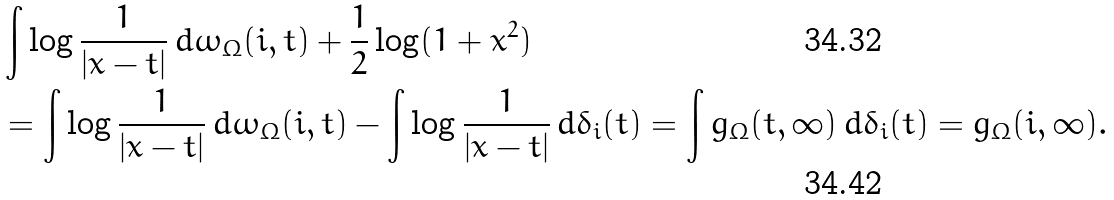<formula> <loc_0><loc_0><loc_500><loc_500>& \int \log \frac { 1 } { | x - t | } \, d \omega _ { \Omega } ( i , t ) + \frac { 1 } { 2 } \log ( 1 + x ^ { 2 } ) \\ & = \int \log \frac { 1 } { | x - t | } \, d \omega _ { \Omega } ( i , t ) - \int \log \frac { 1 } { | x - t | } \, d \delta _ { i } ( t ) = \int g _ { \Omega } ( t , \infty ) \, d \delta _ { i } ( t ) = g _ { \Omega } ( i , \infty ) .</formula> 